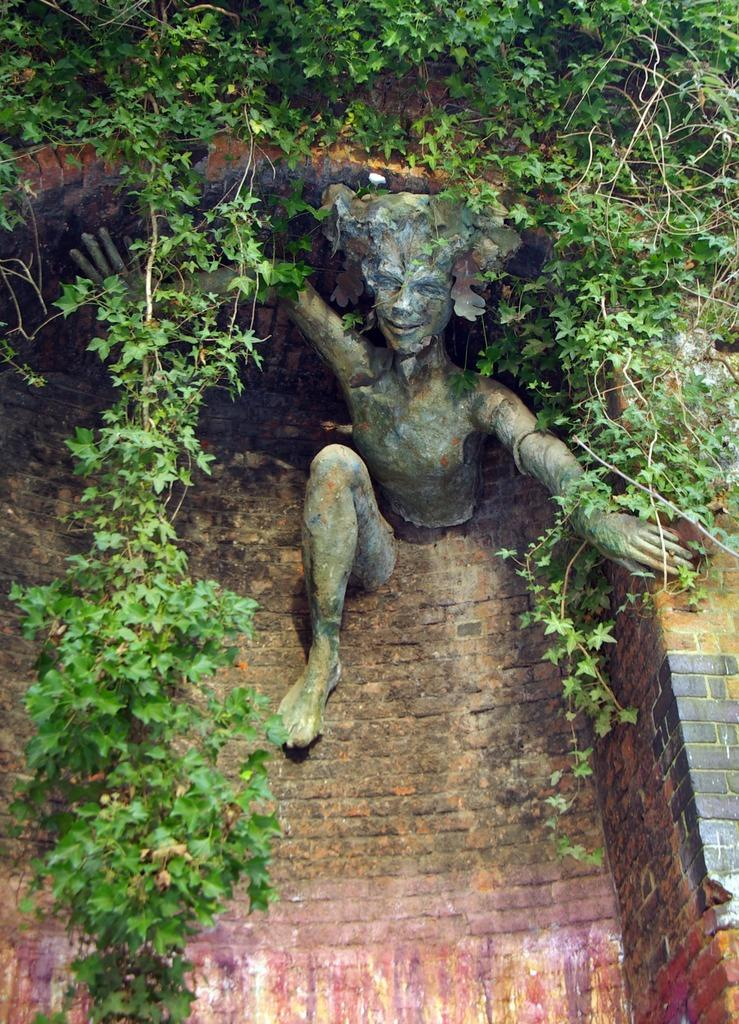What is the main subject of the image? There is a sculpture of a person in the image. What can be seen in the background of the image? There is a wall visible in the image. What type of vegetation is present in the image? Leaves are present in the image. How many hens are on the stage in the image? There are no hens or stage present in the image. What is the amount of water in the image? There is no reference to water in the image, so it cannot be determined how much water is present. 